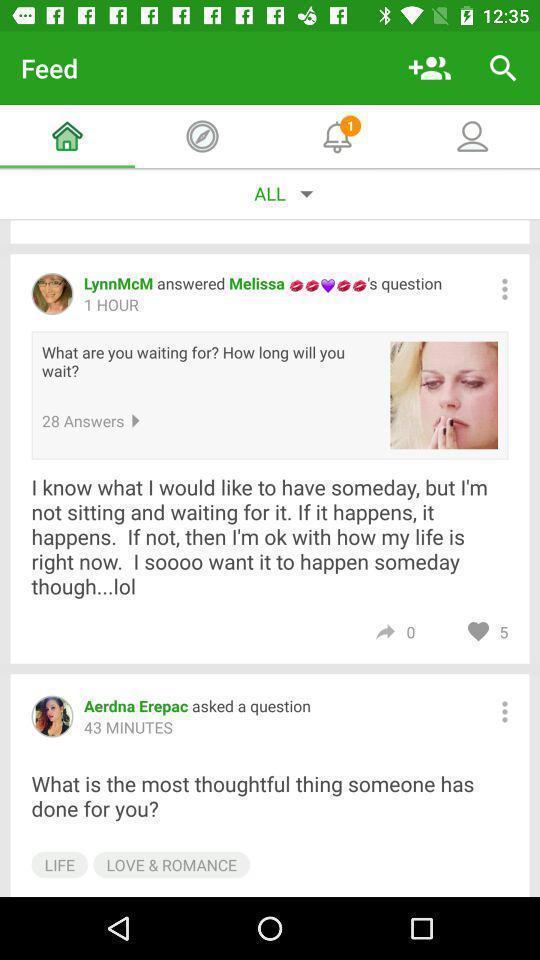Provide a description of this screenshot. Page showing information from a social media app. 